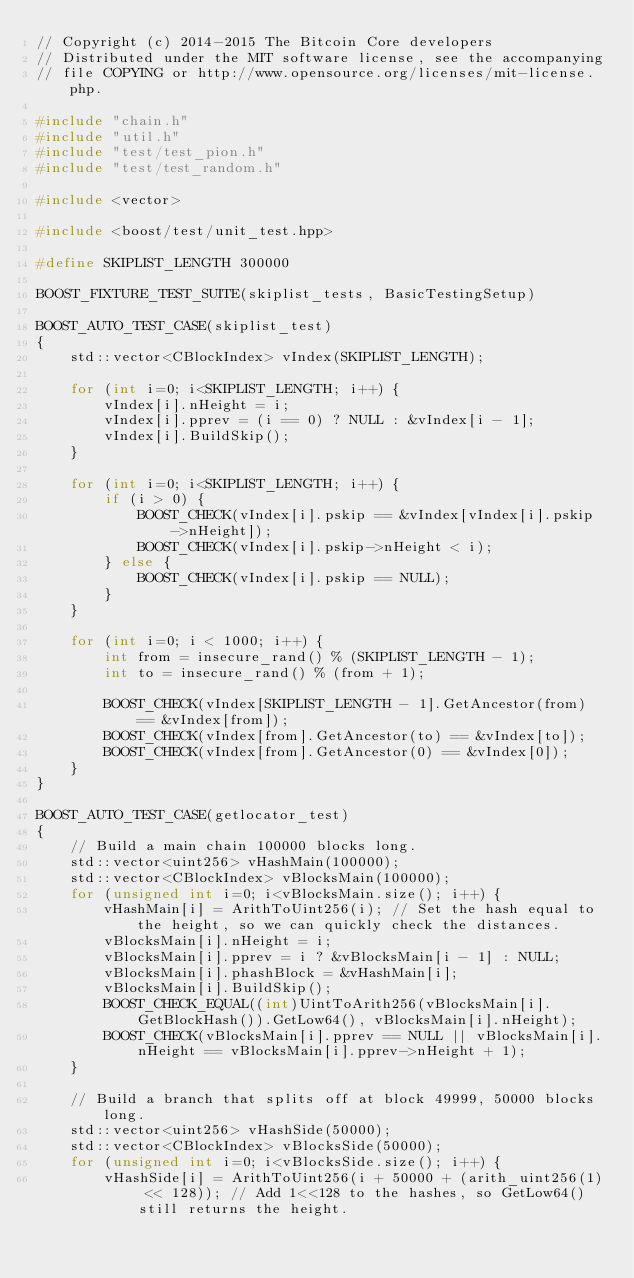Convert code to text. <code><loc_0><loc_0><loc_500><loc_500><_C++_>// Copyright (c) 2014-2015 The Bitcoin Core developers
// Distributed under the MIT software license, see the accompanying
// file COPYING or http://www.opensource.org/licenses/mit-license.php.

#include "chain.h"
#include "util.h"
#include "test/test_pion.h"
#include "test/test_random.h"

#include <vector>

#include <boost/test/unit_test.hpp>

#define SKIPLIST_LENGTH 300000

BOOST_FIXTURE_TEST_SUITE(skiplist_tests, BasicTestingSetup)

BOOST_AUTO_TEST_CASE(skiplist_test)
{
    std::vector<CBlockIndex> vIndex(SKIPLIST_LENGTH);

    for (int i=0; i<SKIPLIST_LENGTH; i++) {
        vIndex[i].nHeight = i;
        vIndex[i].pprev = (i == 0) ? NULL : &vIndex[i - 1];
        vIndex[i].BuildSkip();
    }

    for (int i=0; i<SKIPLIST_LENGTH; i++) {
        if (i > 0) {
            BOOST_CHECK(vIndex[i].pskip == &vIndex[vIndex[i].pskip->nHeight]);
            BOOST_CHECK(vIndex[i].pskip->nHeight < i);
        } else {
            BOOST_CHECK(vIndex[i].pskip == NULL);
        }
    }

    for (int i=0; i < 1000; i++) {
        int from = insecure_rand() % (SKIPLIST_LENGTH - 1);
        int to = insecure_rand() % (from + 1);

        BOOST_CHECK(vIndex[SKIPLIST_LENGTH - 1].GetAncestor(from) == &vIndex[from]);
        BOOST_CHECK(vIndex[from].GetAncestor(to) == &vIndex[to]);
        BOOST_CHECK(vIndex[from].GetAncestor(0) == &vIndex[0]);
    }
}

BOOST_AUTO_TEST_CASE(getlocator_test)
{
    // Build a main chain 100000 blocks long.
    std::vector<uint256> vHashMain(100000);
    std::vector<CBlockIndex> vBlocksMain(100000);
    for (unsigned int i=0; i<vBlocksMain.size(); i++) {
        vHashMain[i] = ArithToUint256(i); // Set the hash equal to the height, so we can quickly check the distances.
        vBlocksMain[i].nHeight = i;
        vBlocksMain[i].pprev = i ? &vBlocksMain[i - 1] : NULL;
        vBlocksMain[i].phashBlock = &vHashMain[i];
        vBlocksMain[i].BuildSkip();
        BOOST_CHECK_EQUAL((int)UintToArith256(vBlocksMain[i].GetBlockHash()).GetLow64(), vBlocksMain[i].nHeight);
        BOOST_CHECK(vBlocksMain[i].pprev == NULL || vBlocksMain[i].nHeight == vBlocksMain[i].pprev->nHeight + 1);
    }

    // Build a branch that splits off at block 49999, 50000 blocks long.
    std::vector<uint256> vHashSide(50000);
    std::vector<CBlockIndex> vBlocksSide(50000);
    for (unsigned int i=0; i<vBlocksSide.size(); i++) {
        vHashSide[i] = ArithToUint256(i + 50000 + (arith_uint256(1) << 128)); // Add 1<<128 to the hashes, so GetLow64() still returns the height.</code> 